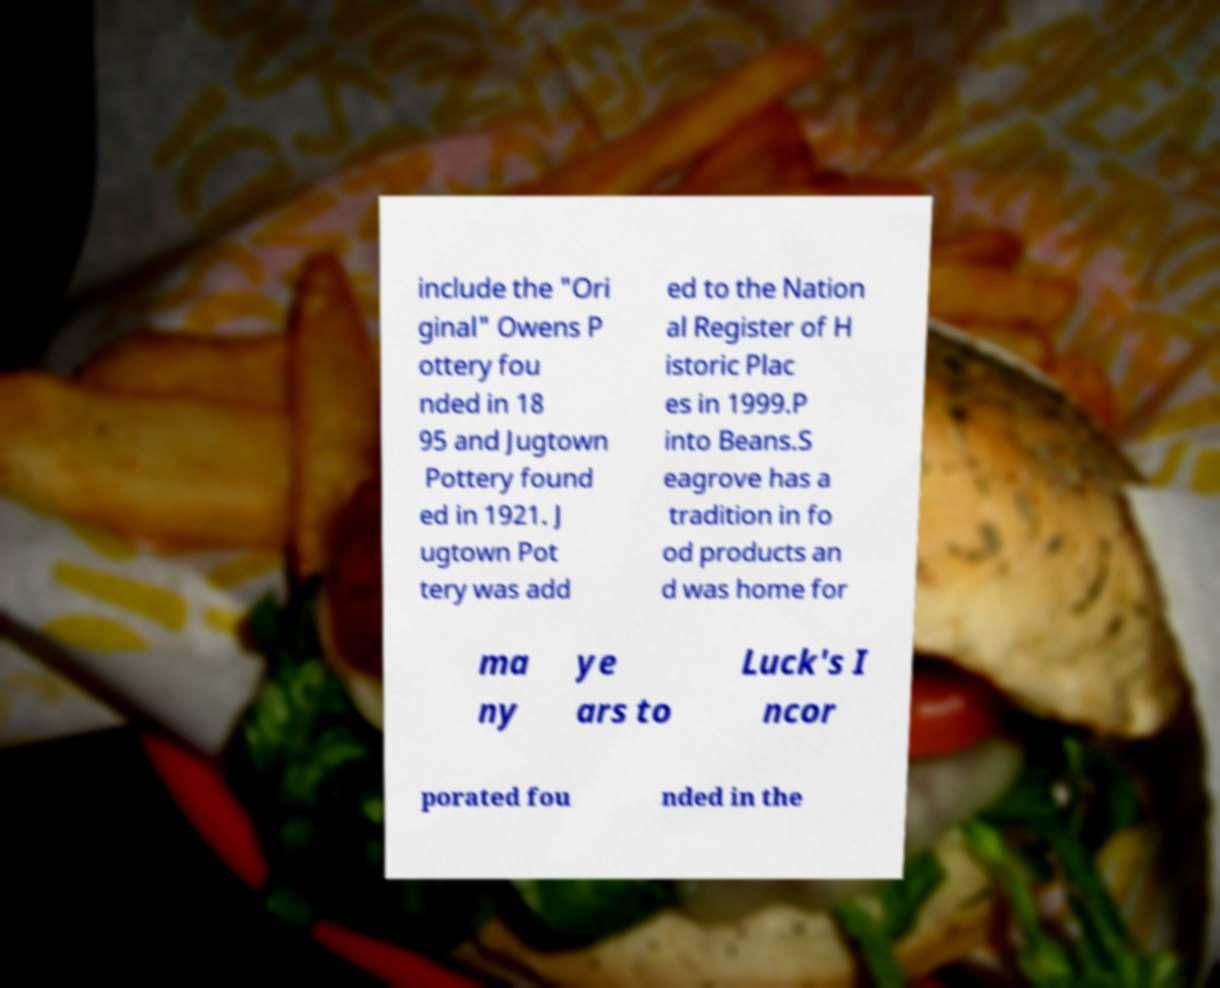Could you extract and type out the text from this image? include the "Ori ginal" Owens P ottery fou nded in 18 95 and Jugtown Pottery found ed in 1921. J ugtown Pot tery was add ed to the Nation al Register of H istoric Plac es in 1999.P into Beans.S eagrove has a tradition in fo od products an d was home for ma ny ye ars to Luck's I ncor porated fou nded in the 